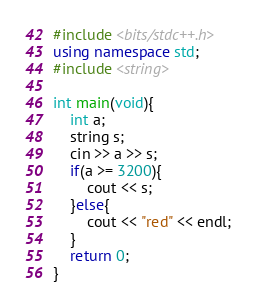<code> <loc_0><loc_0><loc_500><loc_500><_C++_>#include <bits/stdc++.h>
using namespace std;
#include <string>

int main(void){
    int a;
    string s;
    cin >> a >> s;
    if(a >= 3200){
        cout << s;
    }else{
        cout << "red" << endl;
    }
    return 0;
}</code> 